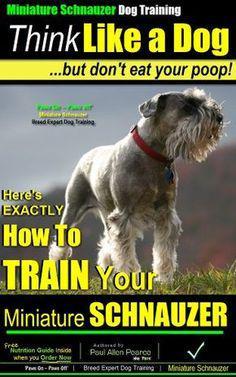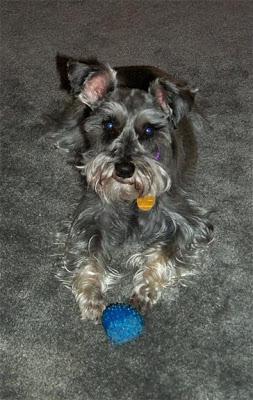The first image is the image on the left, the second image is the image on the right. Evaluate the accuracy of this statement regarding the images: "One dog has its mouth open.". Is it true? Answer yes or no. No. 